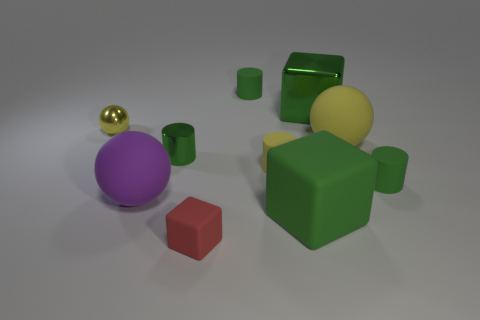The other cube that is the same color as the big metallic cube is what size?
Your answer should be very brief. Large. How many objects are green things or large green matte blocks?
Your answer should be compact. 5. There is a small green shiny cylinder in front of the big green cube that is behind the shiny cylinder; how many yellow matte things are left of it?
Give a very brief answer. 0. There is another green thing that is the same shape as the large green matte object; what material is it?
Your answer should be compact. Metal. What is the material of the ball that is both in front of the metal sphere and to the left of the yellow cylinder?
Your answer should be compact. Rubber. Are there fewer big purple matte things to the left of the big purple sphere than green cylinders that are in front of the tiny green metallic cylinder?
Ensure brevity in your answer.  Yes. What number of other things are the same size as the red matte cube?
Give a very brief answer. 5. What is the shape of the small matte thing that is behind the large green object behind the green shiny thing on the left side of the big rubber block?
Offer a very short reply. Cylinder. How many brown things are tiny spheres or large balls?
Provide a succinct answer. 0. There is a big ball right of the yellow matte cylinder; what number of green shiny cubes are on the right side of it?
Your answer should be compact. 0. 